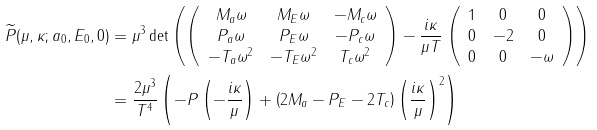<formula> <loc_0><loc_0><loc_500><loc_500>\widetilde { P } ( \mu , \kappa ; a _ { 0 } , E _ { 0 } , 0 ) & = \mu ^ { 3 } \det \left ( \left ( \begin{array} { c c c } M _ { a } \omega & M _ { E } \omega & - M _ { c } \omega \\ P _ { a } \omega & P _ { E } \omega & - P _ { c } \omega \\ - T _ { a } \omega ^ { 2 } & - T _ { E } \omega ^ { 2 } & T _ { c } \omega ^ { 2 } \\ \end{array} \right ) - \frac { i \kappa } { \mu T } \left ( \begin{array} { c c c } 1 & 0 & 0 \\ 0 & - 2 & 0 \\ 0 & 0 & - \omega \\ \end{array} \right ) \right ) \\ & = \frac { 2 \mu ^ { 3 } } { T ^ { 4 } } \left ( - P \left ( - \frac { i \kappa } { \mu } \right ) + \left ( 2 M _ { a } - P _ { E } - 2 T _ { c } \right ) \left ( \frac { i \kappa } { \mu } \right ) ^ { 2 } \right )</formula> 